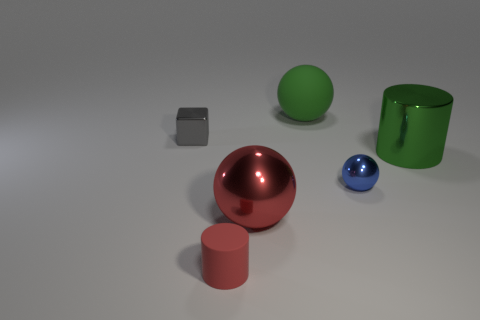There is a big thing that is the same color as the big metal cylinder; what is it made of?
Your answer should be very brief. Rubber. There is another green object that is the same size as the green metal thing; what is it made of?
Your response must be concise. Rubber. Does the red cylinder have the same material as the large green thing to the right of the blue shiny object?
Offer a very short reply. No. Is the color of the sphere that is behind the small gray cube the same as the large cylinder?
Your answer should be compact. Yes. There is a tiny thing that is both on the right side of the metallic block and left of the small metallic ball; what material is it made of?
Offer a terse response. Rubber. The green cylinder has what size?
Your answer should be very brief. Large. Is the color of the large cylinder the same as the small object left of the tiny red object?
Your answer should be very brief. No. How many other things are there of the same color as the large cylinder?
Your response must be concise. 1. Does the green thing left of the green cylinder have the same size as the red thing that is behind the matte cylinder?
Your answer should be compact. Yes. What color is the object that is to the left of the red rubber cylinder?
Your answer should be very brief. Gray. 